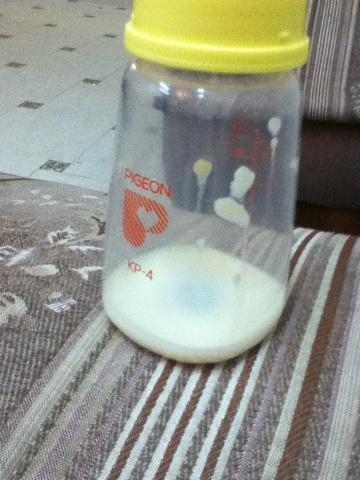What is that? This is a small Pigeon brand baby bottle containing a residual amount of milk, probably used for feeding infants. The measurement markings show that it's a small bottle designed for small servings suitable for a baby's meal. 